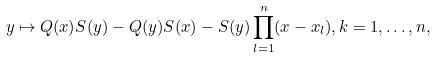Convert formula to latex. <formula><loc_0><loc_0><loc_500><loc_500>y \mapsto { Q } ( x ) { S } ( y ) - { Q } ( y ) { S } ( x ) - { S } ( y ) \prod _ { l = 1 } ^ { n } ( x - { x } _ { l } ) , k = 1 , \dots , n ,</formula> 